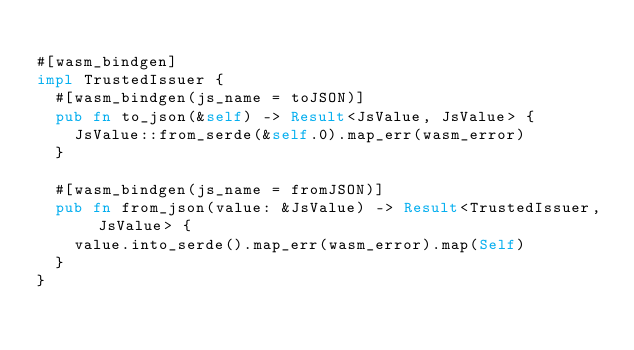Convert code to text. <code><loc_0><loc_0><loc_500><loc_500><_Rust_>
#[wasm_bindgen]
impl TrustedIssuer {
  #[wasm_bindgen(js_name = toJSON)]
  pub fn to_json(&self) -> Result<JsValue, JsValue> {
    JsValue::from_serde(&self.0).map_err(wasm_error)
  }

  #[wasm_bindgen(js_name = fromJSON)]
  pub fn from_json(value: &JsValue) -> Result<TrustedIssuer, JsValue> {
    value.into_serde().map_err(wasm_error).map(Self)
  }
}
</code> 